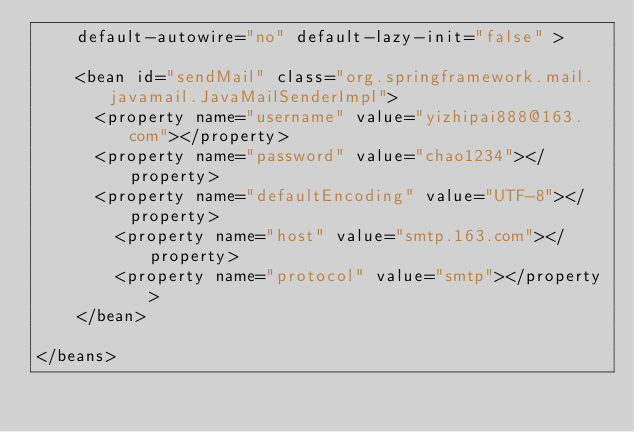Convert code to text. <code><loc_0><loc_0><loc_500><loc_500><_XML_>    default-autowire="no" default-lazy-init="false" >
    
    <bean id="sendMail" class="org.springframework.mail.javamail.JavaMailSenderImpl">
    	<property name="username" value="yizhipai888@163.com"></property>
    	<property name="password" value="chao1234"></property>
    	<property name="defaultEncoding" value="UTF-8"></property>
        <property name="host" value="smtp.163.com"></property>
        <property name="protocol" value="smtp"></property>
    </bean>
    
</beans>
</code> 